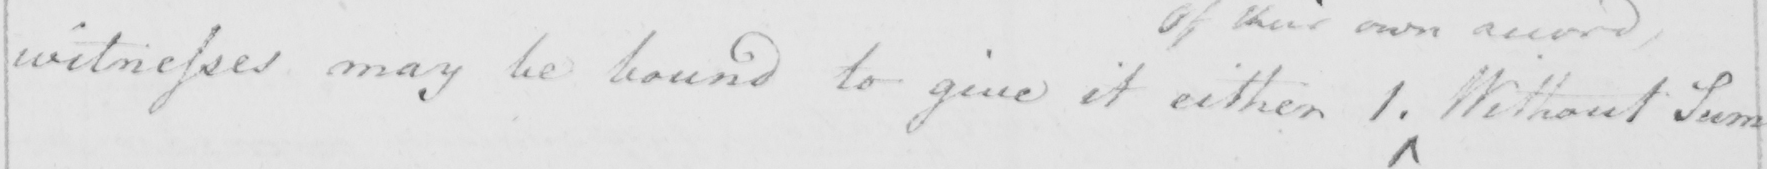What does this handwritten line say? witnesses may be bound to give it either 1 . Without Sum= 